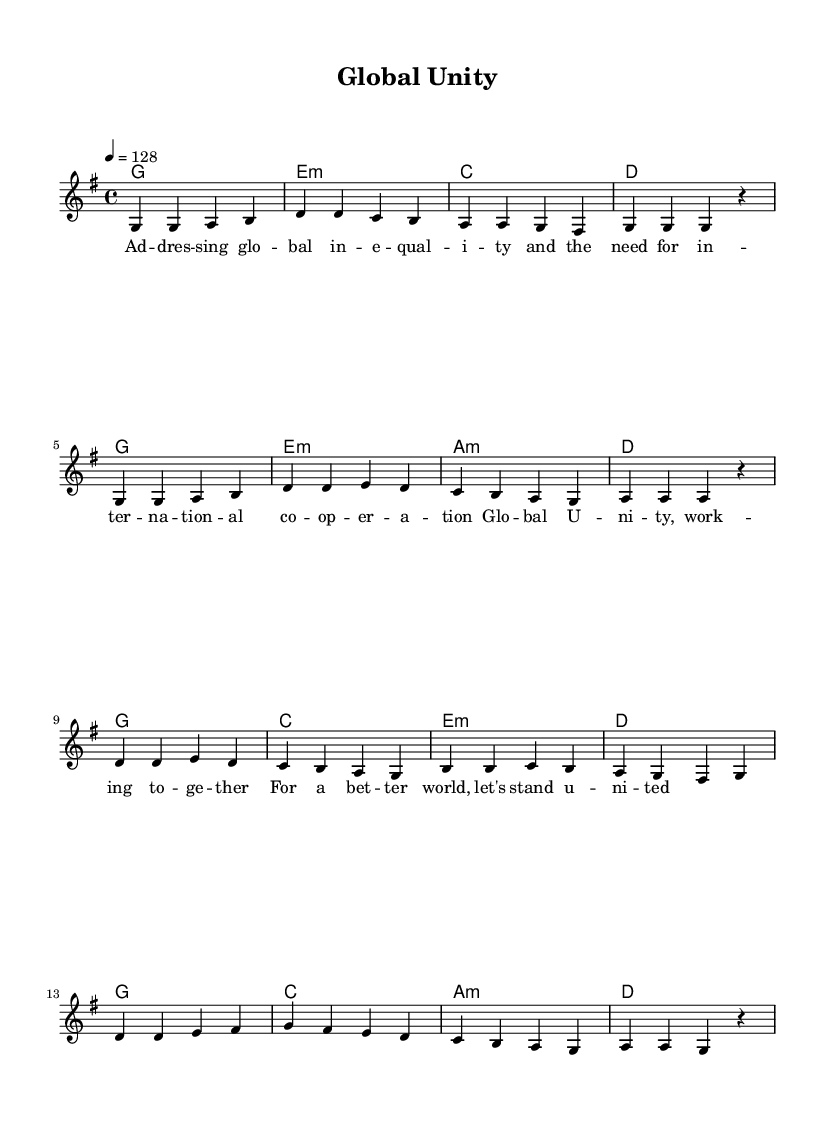What is the key signature of this music? The key signature is G major, which has one sharp (F#). This can be determined by looking at the key signature notation at the beginning of the sheet music.
Answer: G major What is the time signature of this music? The time signature displayed is 4/4, which indicates that there are four beats in a measure and the quarter note gets one beat. This is found at the beginning of the sheet music as well.
Answer: 4/4 What is the tempo marking in this piece? The tempo marking indicates a speed of 128 beats per minute, which can be observed in the tempo command at the beginning of the score.
Answer: 128 How many measures are there in the verse section? Counting the measures in the verse section between the lyric lines reveals a total of 8 measures. This can be inferred by analyzing the notation and how the melody is structured.
Answer: 8 What is the primary theme of the lyrics in this song? The lyrics discuss global inequality and the need for international cooperation, aiming for global unity. This theme can be derived from analyzing the content of the lyrics provided.
Answer: Global unity What type of chords are primarily used in the harmony section? The harmony section primarily uses major and minor chords, which is common in K-Pop to create emotional contrasts. This is evident by looking at the chord notations throughout the score.
Answer: Major and minor chords What does the repeated section in the chorus suggest about the song's message? The repetition in the chorus emphasizes the urgency and importance of the message about global unity and cooperation, a common technique in K-Pop to reinforce key themes. This can be understood by observing the structure and placement of the chorus in the sheet music.
Answer: Urgency 